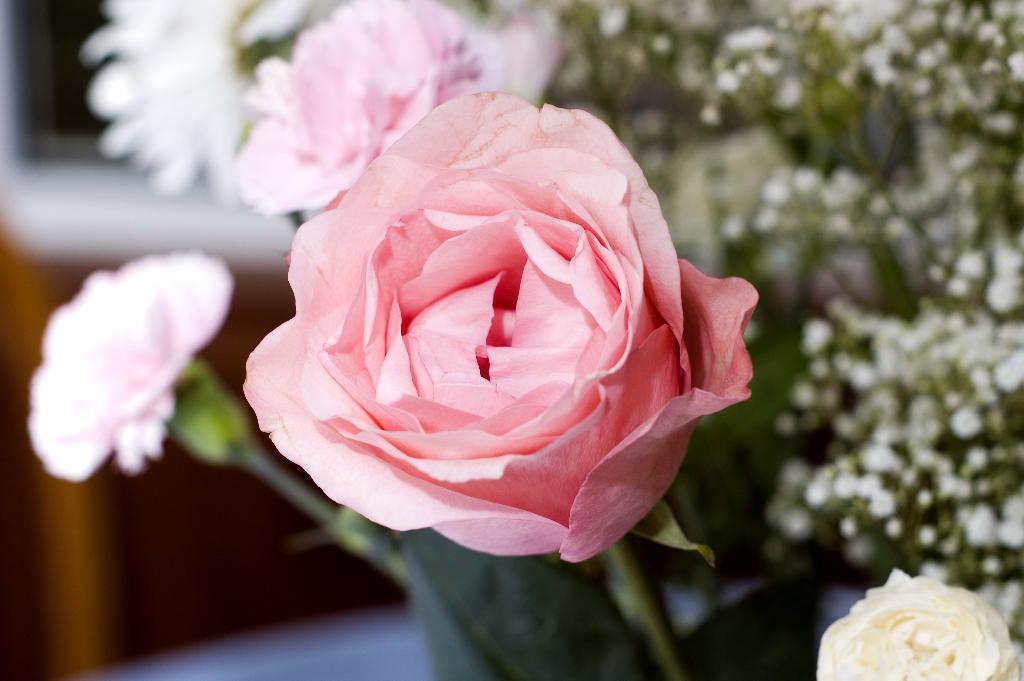Can you describe this image briefly? Here we can see flowers and on the right there is a plant with small flowers. In the background the image is blur but we can see objects. 